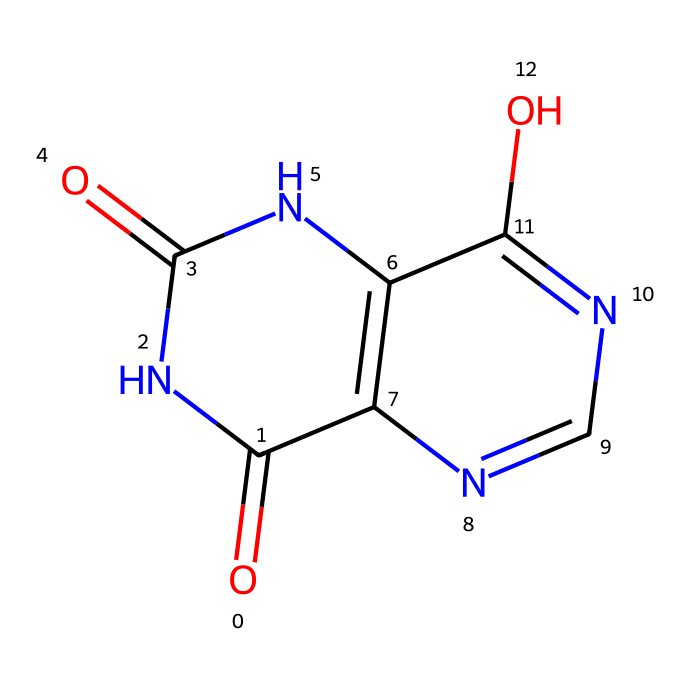What is the molecular formula of uric acid? To find the molecular formula, count the number of each type of atom in the SMILES representation. There are 5 carbon (C) atoms, 4 nitrogen (N) atoms, 4 oxygen (O) atoms, and 2 hydrogen (H) atoms. Thus, the molecular formula is C5H4N4O3.
Answer: C5H4N4O3 How many nitrogen atoms are present in uric acid? By examining the structure indicated by the SMILES, we can see that there are 4 nitrogen atoms included in the molecule.
Answer: 4 What type of functional groups are present in uric acid? The molecular structure reveals that uric acid has multiple carbonyl (C=O) groups and an amine (NH) group. These contribute to its chemical reactivity and properties.
Answer: carbonyl and amine What is the primary role of uric acid in the human body? Uric acid primarily serves as a waste product resulting from the metabolism of purines in nucleic acids, which is then excreted via urine.
Answer: waste product What type of compound is uric acid classified as? Uric acid is classified as a purine derivative, specifically an organic compound that functions within nucleic acid metabolism.
Answer: purine derivative How does the structure of uric acid contribute to urinary stone formation? The high concentration of uric acid in urine can lead to crystallization, forming uric acid stones when conditions favor low solubility. Factors such as dehydration increase this risk due to elevated levels.
Answer: crystallization 